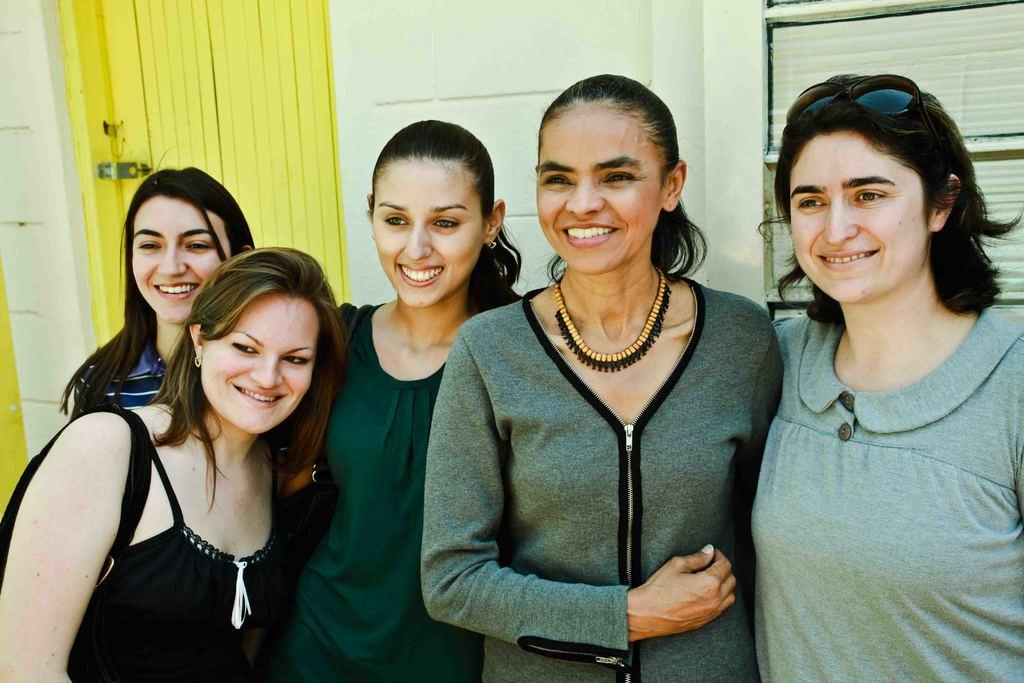Who is present in the image? There are ladies in the image. What expression do the ladies have? The ladies are smiling. Can you describe any specific accessory worn by one of the ladies? One lady on the right is wearing goggles on her head. What can be seen in the background of the image? There is a wall in the background of the image. What is the tendency of the fire in the image? There is no fire present in the image. 